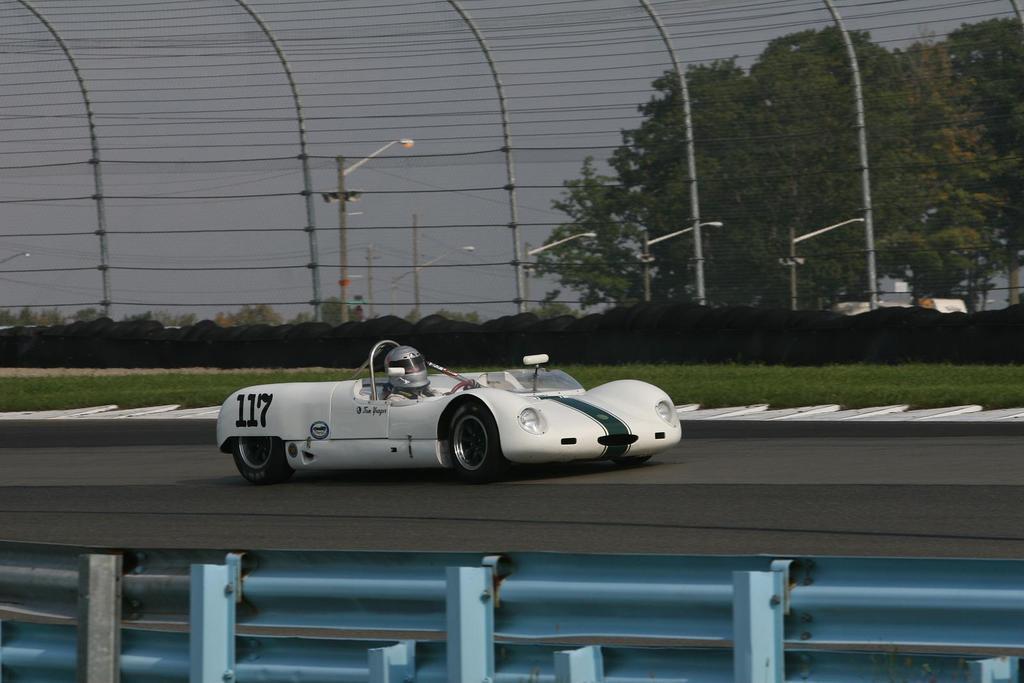Describe this image in one or two sentences. In this image in the center there is a car moving on the road with the person sitting inside it. In the background there are plants, poles, trees and there is grass on the ground and there is a fence. In the front there is an object which is blue in colour. 